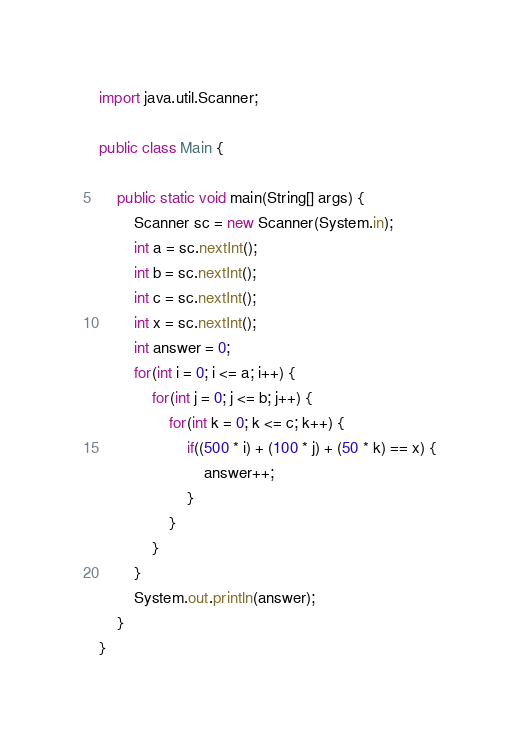<code> <loc_0><loc_0><loc_500><loc_500><_Java_>import java.util.Scanner;

public class Main {

	public static void main(String[] args) {
		Scanner sc = new Scanner(System.in);
		int a = sc.nextInt();
		int b = sc.nextInt();
		int c = sc.nextInt();
		int x = sc.nextInt();
		int answer = 0;
		for(int i = 0; i <= a; i++) {
			for(int j = 0; j <= b; j++) {
				for(int k = 0; k <= c; k++) {
					if((500 * i) + (100 * j) + (50 * k) == x) {
						answer++;
					}
				}
			}
		}
		System.out.println(answer);
	}
}</code> 